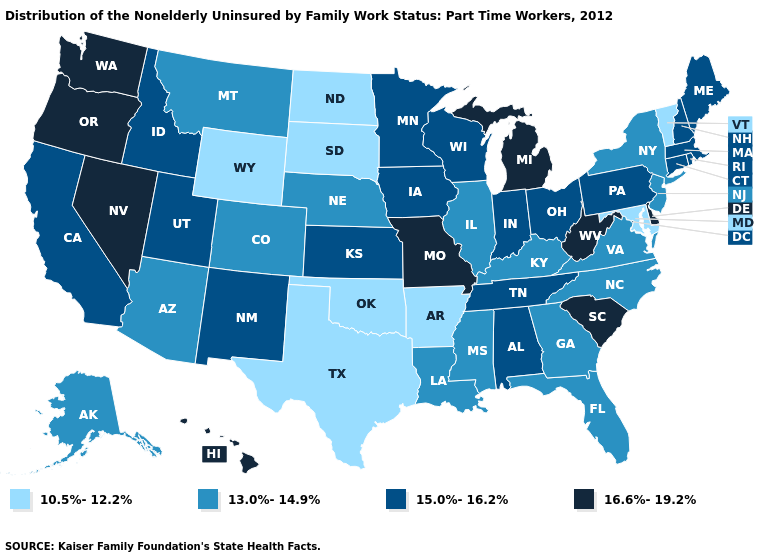What is the value of Utah?
Write a very short answer. 15.0%-16.2%. Which states have the highest value in the USA?
Be succinct. Delaware, Hawaii, Michigan, Missouri, Nevada, Oregon, South Carolina, Washington, West Virginia. What is the value of South Dakota?
Write a very short answer. 10.5%-12.2%. Which states hav the highest value in the South?
Keep it brief. Delaware, South Carolina, West Virginia. Name the states that have a value in the range 10.5%-12.2%?
Quick response, please. Arkansas, Maryland, North Dakota, Oklahoma, South Dakota, Texas, Vermont, Wyoming. Name the states that have a value in the range 16.6%-19.2%?
Quick response, please. Delaware, Hawaii, Michigan, Missouri, Nevada, Oregon, South Carolina, Washington, West Virginia. What is the value of Wyoming?
Write a very short answer. 10.5%-12.2%. What is the lowest value in the MidWest?
Short answer required. 10.5%-12.2%. Which states have the lowest value in the West?
Write a very short answer. Wyoming. Name the states that have a value in the range 15.0%-16.2%?
Write a very short answer. Alabama, California, Connecticut, Idaho, Indiana, Iowa, Kansas, Maine, Massachusetts, Minnesota, New Hampshire, New Mexico, Ohio, Pennsylvania, Rhode Island, Tennessee, Utah, Wisconsin. Name the states that have a value in the range 13.0%-14.9%?
Give a very brief answer. Alaska, Arizona, Colorado, Florida, Georgia, Illinois, Kentucky, Louisiana, Mississippi, Montana, Nebraska, New Jersey, New York, North Carolina, Virginia. Does the map have missing data?
Answer briefly. No. What is the value of Hawaii?
Give a very brief answer. 16.6%-19.2%. Name the states that have a value in the range 15.0%-16.2%?
Short answer required. Alabama, California, Connecticut, Idaho, Indiana, Iowa, Kansas, Maine, Massachusetts, Minnesota, New Hampshire, New Mexico, Ohio, Pennsylvania, Rhode Island, Tennessee, Utah, Wisconsin. Is the legend a continuous bar?
Keep it brief. No. 